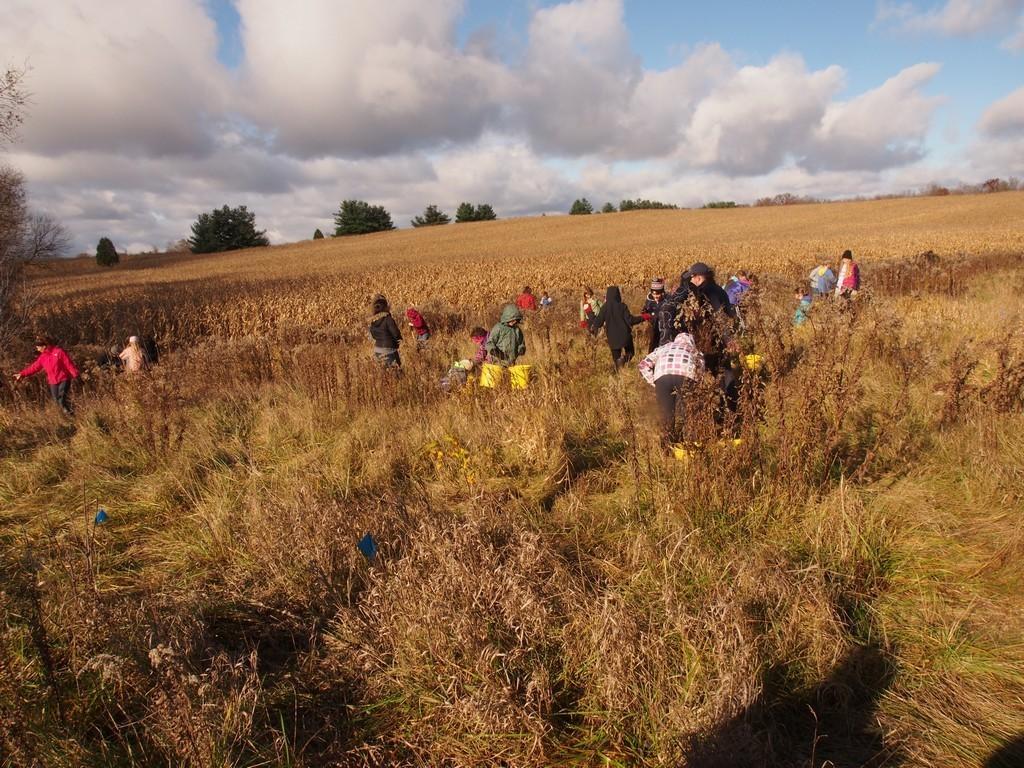How would you summarize this image in a sentence or two? In this image we can see grass and a few people standing and in the background there are trees and sky with clouds. 